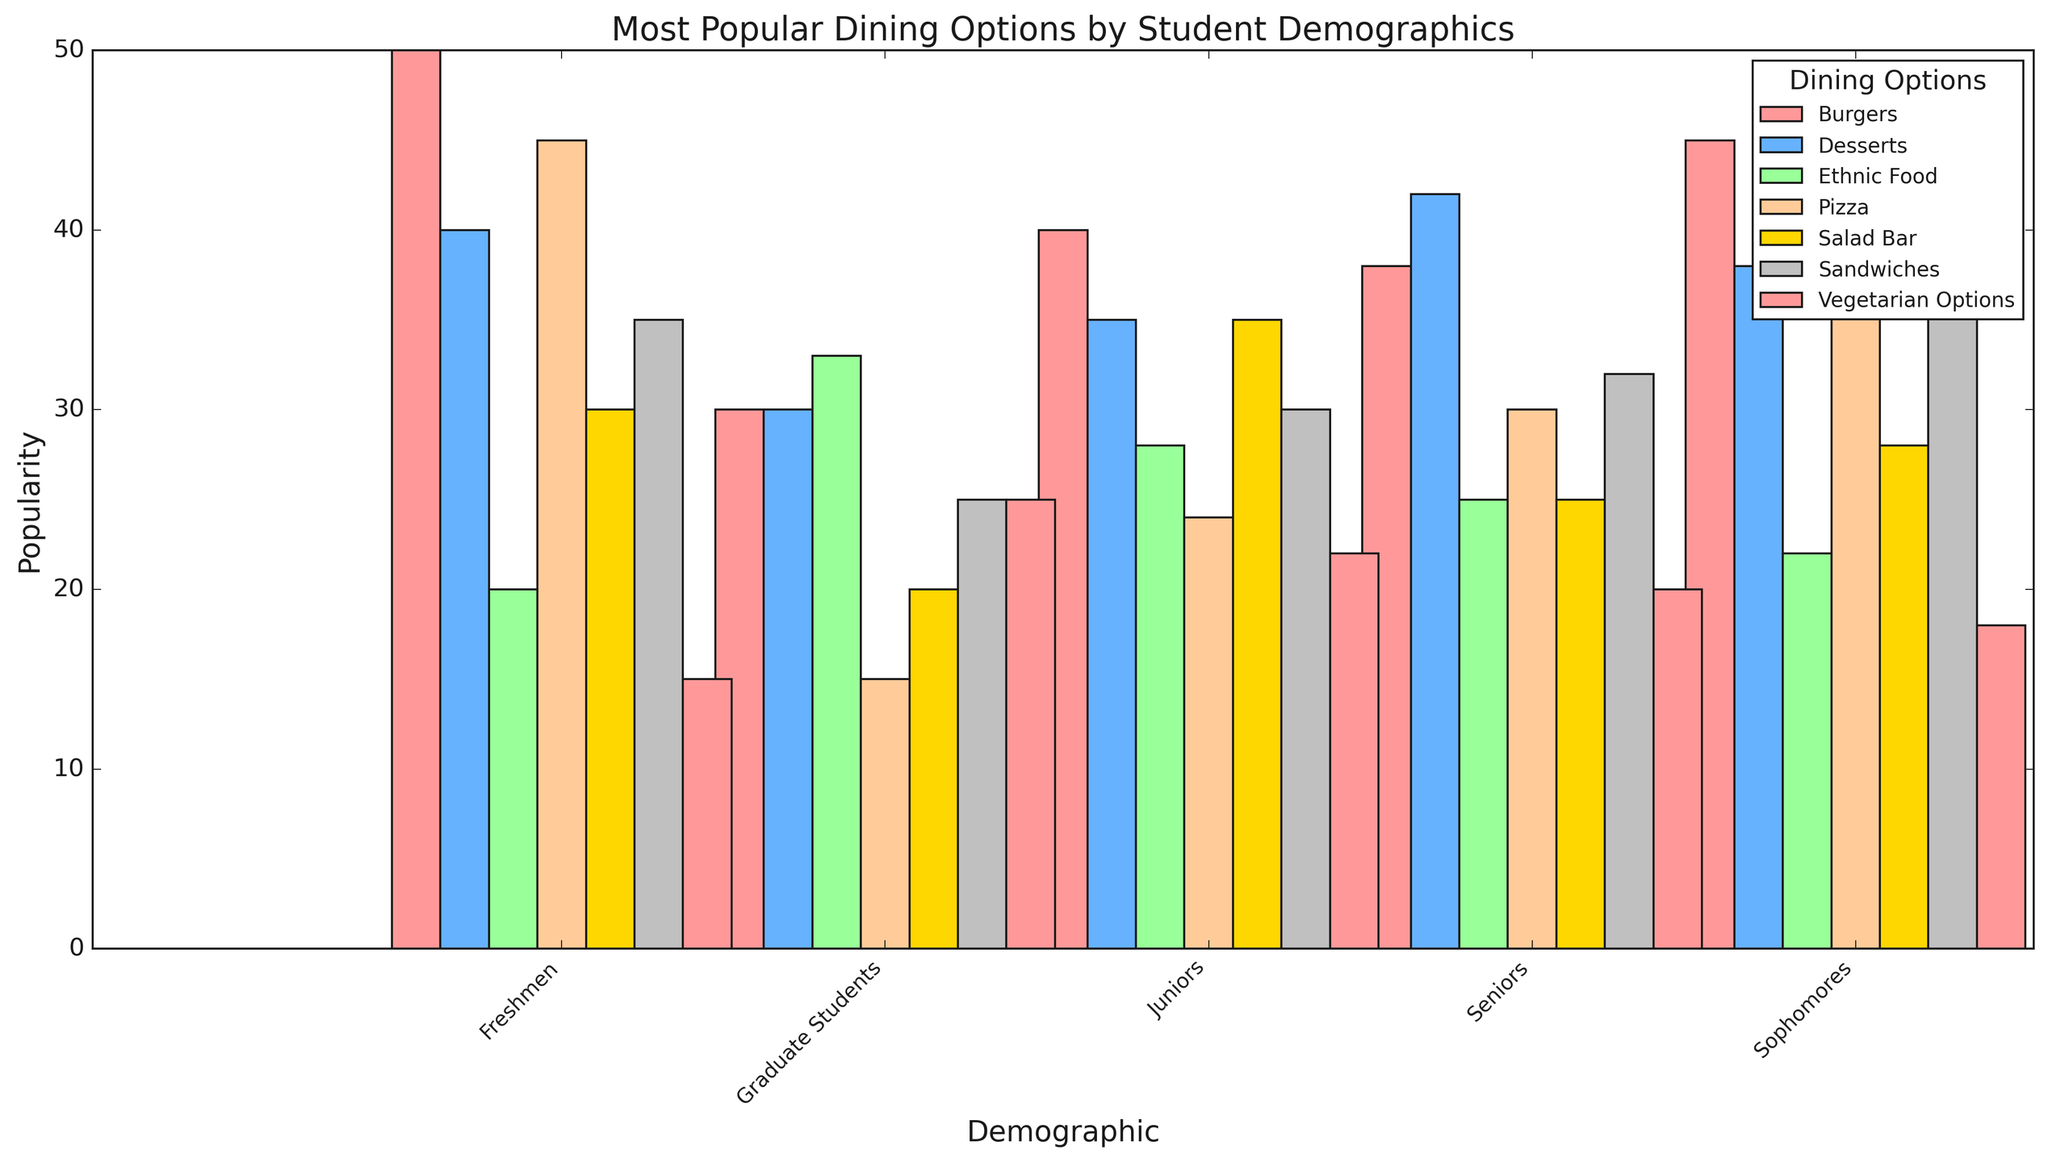What is the most popular dining option among freshmen? The bar representing burgers is the highest for the freshmen demographic.
Answer: Burgers Which demographic group prefers salads the most? By comparing the height of the bars for Salad Bar across all the demographic groups, juniors have the highest bar.
Answer: Juniors What is the difference in popularity between burgers and vegetarian options among graduate students? The popularity of burgers among graduate students is 30 and for vegetarian options, it is 25. Subtracting 25 from 30 gives 5.
Answer: 5 Which dining option shows consistent popularity across all demographics? By observing the height of all bars for each dining option across all demographics, pizza shows relatively consistent heights.
Answer: Pizza What is the combined popularity of ethnic food and desserts among sophomores? For sophomores, the popularity of ethnic food is 22 and for desserts, it is 38. Adding these values gives 22 + 38 = 60.
Answer: 60 Which demographic has the least preference for vegetarian options? By comparing the height of the bars for vegetarian options, freshmen have the smallest bar.
Answer: Freshmen How many more students prefer sandwiches over pizza among seniors? The popularity of sandwiches among seniors is 32 and pizza is 30. Subtracting 30 from 32 gives 2.
Answer: 2 Which dining option is the least popular among juniors? The bar for vegetarian options is the shortest for juniors, indicating it is the least popular.
Answer: Vegetarian options What is the average popularity of burgers across all demographics? The popularity values for burgers are 50, 45, 40, 38, and 30. Summing these values gives 203, and dividing by the number of demographics (5) gives an average of 203 / 5 = 40.6
Answer: 40.6 Which dining option sees the highest variability in popularity across demographics? Observing the differences in bar heights for each dining option across demographics, burgers show the largest range from 30 to 50.
Answer: Burgers 